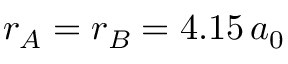<formula> <loc_0><loc_0><loc_500><loc_500>r _ { A } = r _ { B } = 4 . 1 5 \, a _ { 0 }</formula> 